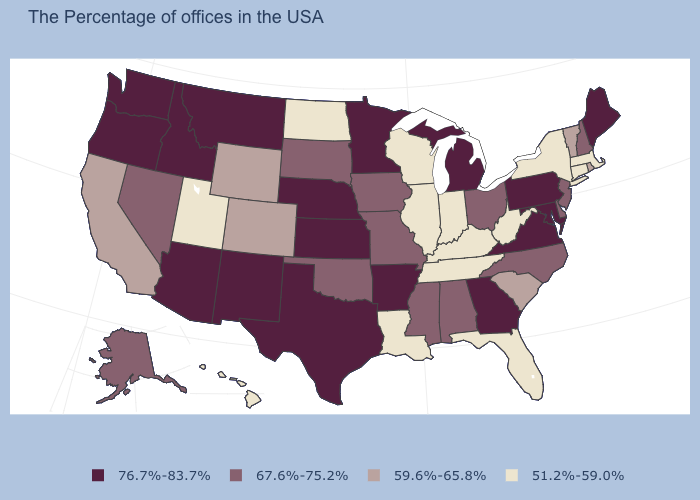What is the highest value in the Northeast ?
Keep it brief. 76.7%-83.7%. Is the legend a continuous bar?
Short answer required. No. What is the value of Alaska?
Write a very short answer. 67.6%-75.2%. What is the value of South Dakota?
Write a very short answer. 67.6%-75.2%. Among the states that border Maryland , which have the highest value?
Quick response, please. Pennsylvania, Virginia. What is the value of Ohio?
Quick response, please. 67.6%-75.2%. What is the value of South Carolina?
Quick response, please. 59.6%-65.8%. Name the states that have a value in the range 67.6%-75.2%?
Concise answer only. New Hampshire, New Jersey, Delaware, North Carolina, Ohio, Alabama, Mississippi, Missouri, Iowa, Oklahoma, South Dakota, Nevada, Alaska. Name the states that have a value in the range 76.7%-83.7%?
Be succinct. Maine, Maryland, Pennsylvania, Virginia, Georgia, Michigan, Arkansas, Minnesota, Kansas, Nebraska, Texas, New Mexico, Montana, Arizona, Idaho, Washington, Oregon. What is the value of Idaho?
Be succinct. 76.7%-83.7%. Does the map have missing data?
Give a very brief answer. No. Name the states that have a value in the range 67.6%-75.2%?
Be succinct. New Hampshire, New Jersey, Delaware, North Carolina, Ohio, Alabama, Mississippi, Missouri, Iowa, Oklahoma, South Dakota, Nevada, Alaska. What is the lowest value in the Northeast?
Short answer required. 51.2%-59.0%. Does the map have missing data?
Be succinct. No. Does Delaware have the highest value in the USA?
Concise answer only. No. 